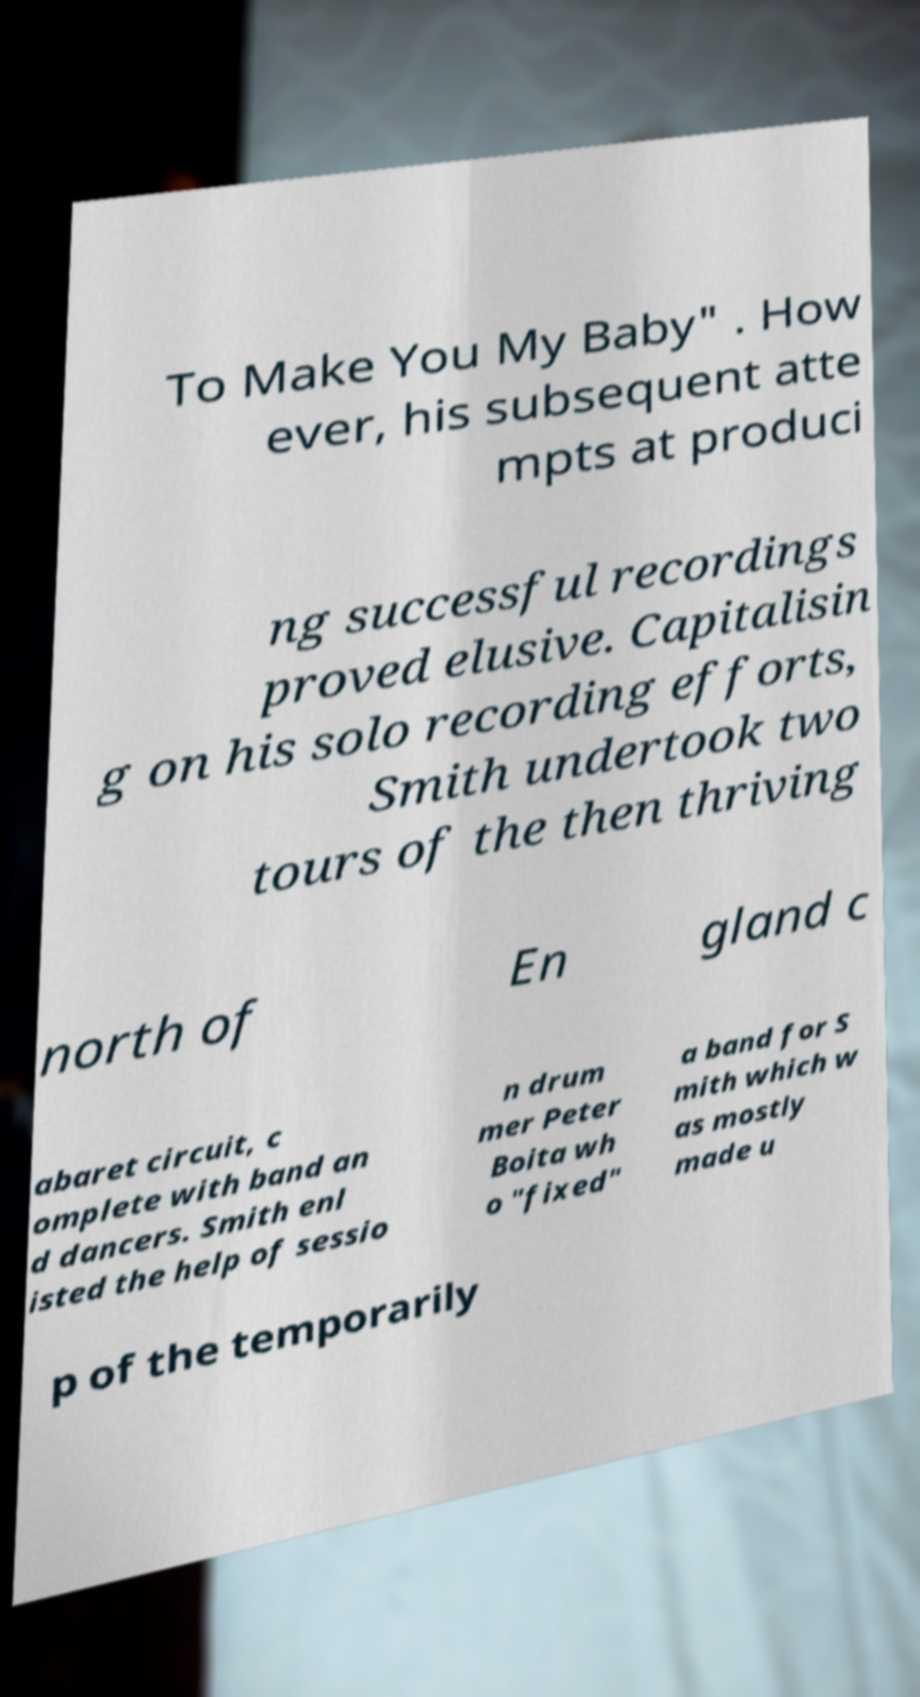Could you extract and type out the text from this image? To Make You My Baby" . How ever, his subsequent atte mpts at produci ng successful recordings proved elusive. Capitalisin g on his solo recording efforts, Smith undertook two tours of the then thriving north of En gland c abaret circuit, c omplete with band an d dancers. Smith enl isted the help of sessio n drum mer Peter Boita wh o "fixed" a band for S mith which w as mostly made u p of the temporarily 